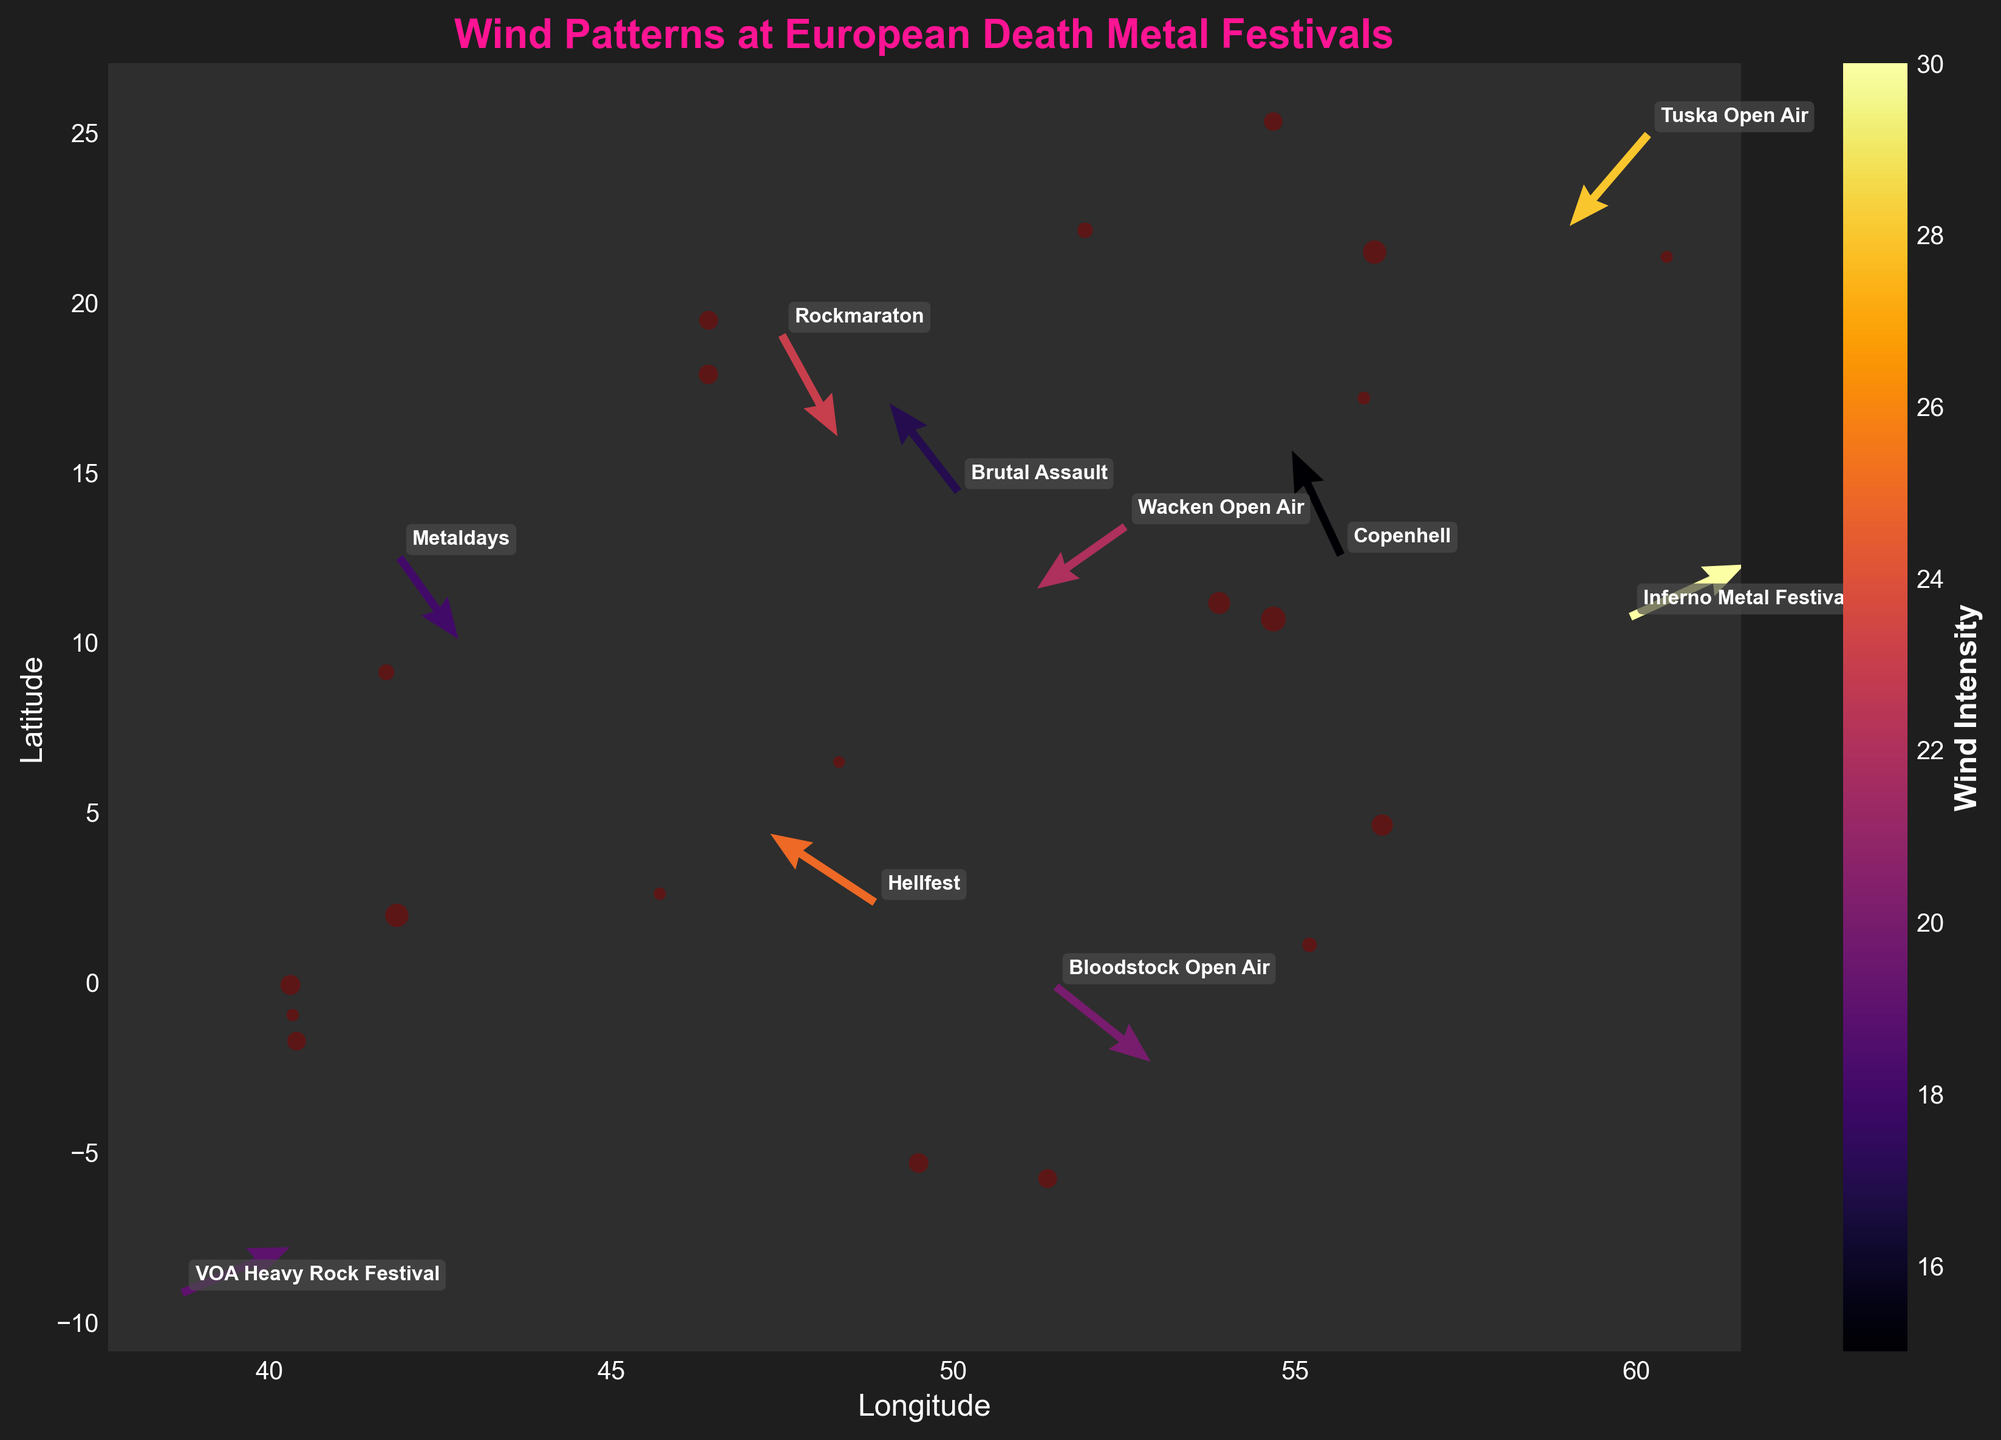What is the title of the plot? The title of the plot is usually prominently displayed at the top of the figure. In this plot, it is clearly labeled as 'Wind Patterns at European Death Metal Festivals'.
Answer: Wind Patterns at European Death Metal Festivals What are the units on the colorbar? The colorbar usually indicates what variable is being represented by color. In this case, the colorbar's label is 'Wind Intensity', which means it shows the intensity of wind patterns in the plot.
Answer: Wind Intensity How many data points are there in the plot? Each festival represents a data point in the plot. Counting all the festivals listed in the data, we see that there are 10 unique data points.
Answer: 10 What direction is the wind at Hellfest? The quiver arrow for Hellfest is located at its corresponding coordinates and points according to the (u, v) vector. From the data, Hellfest's (u, v) vector is (-3.2, 2.1), meaning the arrow is pointing towards the northwest.
Answer: Northwest Which festival has the highest wind intensity? To find this, we look at the color corresponding to the highest value on the colorbar. In this case, the highest wind intensity in the data is 30, which corresponds to 'Inferno Metal Festival'.
Answer: Inferno Metal Festival Which two festivals have the closest wind intensities? By analyzing the intensity values in the data, the closest intensities are 17 and 18, which correspond to 'Brutal Assault' and 'Metaldays' respectively. Thus these two festivals have almost the same wind intensity.
Answer: Brutal Assault and Metaldays What is the average wind intensity across all festivals? Adding up all intensity values: 25 + 18 + 22 + 30 + 15 + 20 + 17 + 23 + 19 + 28, which equals 217. Dividing by the number of festivals (10) gives us 217/10 = 21.7.
Answer: 21.7 How does the wind pattern at Inferno Metal Festival compare to that at Wacken Open Air? Inferno Metal Festival has a (u, v) vector of (3.5, 1.6) pointing northeast, while Wacken Open Air has a vector of (-2.7, -1.9) pointing southwest.
Answer: Inferno Metal Festival: Northeast, Wacken Open Air: Southwest What longitude is closest to the easternmost point? The easternmost point can be found by looking at the highest longitude value in the dataset which is 24.9384 for 'Tuska Open Air' in Helsinki, Finland.
Answer: 24.9384 